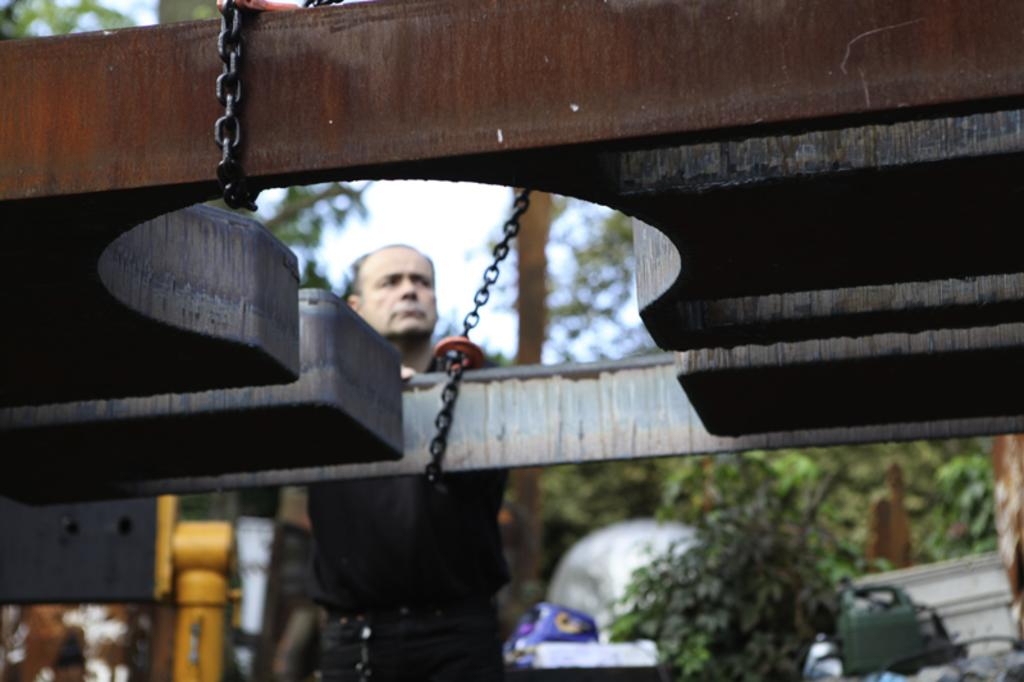What type of metal object with chains can be seen in the image? There is a metal object with chains in the image, but the specific type is not mentioned. Who is present in the image? A man is standing in the image. What type of natural vegetation is visible in the image? There are trees in the image. What else can be seen in the image besides the metal object, man, and trees? There are other objects in the image, but their specific nature is not mentioned. What is visible in the background of the image? The sky is visible in the background of the image, but it is blurry. What type of produce is being sold by the man in the image? There is no produce visible in the image, and the man's actions are not described. What type of beef is being prepared by the trees in the image? There is no beef present in the image, and the trees are not involved in any food preparation. 